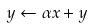Convert formula to latex. <formula><loc_0><loc_0><loc_500><loc_500>y \leftarrow \alpha x + y</formula> 